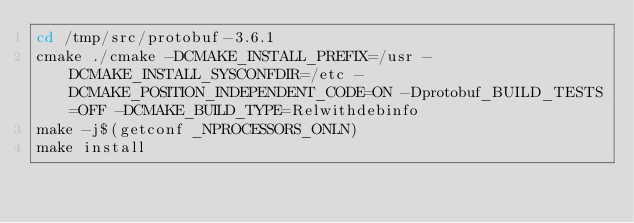<code> <loc_0><loc_0><loc_500><loc_500><_Bash_>cd /tmp/src/protobuf-3.6.1
cmake ./cmake -DCMAKE_INSTALL_PREFIX=/usr -DCMAKE_INSTALL_SYSCONFDIR=/etc -DCMAKE_POSITION_INDEPENDENT_CODE=ON -Dprotobuf_BUILD_TESTS=OFF -DCMAKE_BUILD_TYPE=Relwithdebinfo
make -j$(getconf _NPROCESSORS_ONLN)
make install
</code> 